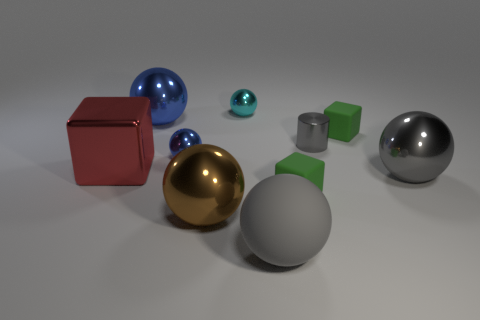The big gray ball that is behind the green matte object that is in front of the metal cylinder is made of what material?
Give a very brief answer. Metal. Are there any matte blocks that have the same color as the big matte object?
Keep it short and to the point. No. Do the cyan metal sphere and the green matte thing that is in front of the red metal cube have the same size?
Your answer should be very brief. Yes. There is a large gray object that is behind the object that is in front of the big brown metallic object; how many metal things are in front of it?
Provide a succinct answer. 1. There is a brown metallic thing; how many tiny cyan objects are to the left of it?
Offer a terse response. 0. What is the color of the big metal ball behind the tiny metal object on the left side of the tiny cyan metal thing?
Keep it short and to the point. Blue. How many other things are made of the same material as the tiny gray cylinder?
Offer a terse response. 6. Is the number of large matte objects behind the small cyan thing the same as the number of purple shiny cylinders?
Your answer should be very brief. Yes. There is a ball that is right of the green thing that is in front of the small metal thing that is on the right side of the tiny cyan ball; what is its material?
Ensure brevity in your answer.  Metal. There is a metal sphere that is to the right of the big gray rubber thing; what is its color?
Make the answer very short. Gray. 